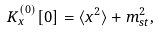<formula> <loc_0><loc_0><loc_500><loc_500>K _ { x } ^ { ( 0 ) } [ 0 ] = \langle x ^ { 2 } \rangle + m ^ { 2 } _ { s t } ,</formula> 